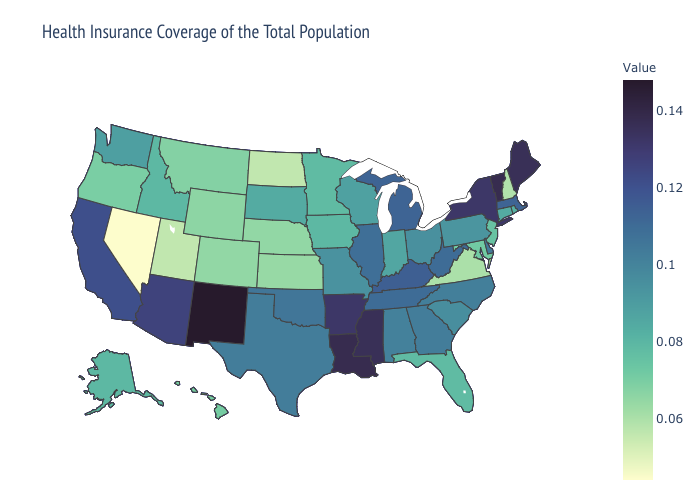Which states have the lowest value in the USA?
Give a very brief answer. Nevada. Which states have the highest value in the USA?
Short answer required. New Mexico. Does Wisconsin have the highest value in the USA?
Be succinct. No. Among the states that border Georgia , does South Carolina have the highest value?
Write a very short answer. No. Which states hav the highest value in the Northeast?
Concise answer only. Vermont. 